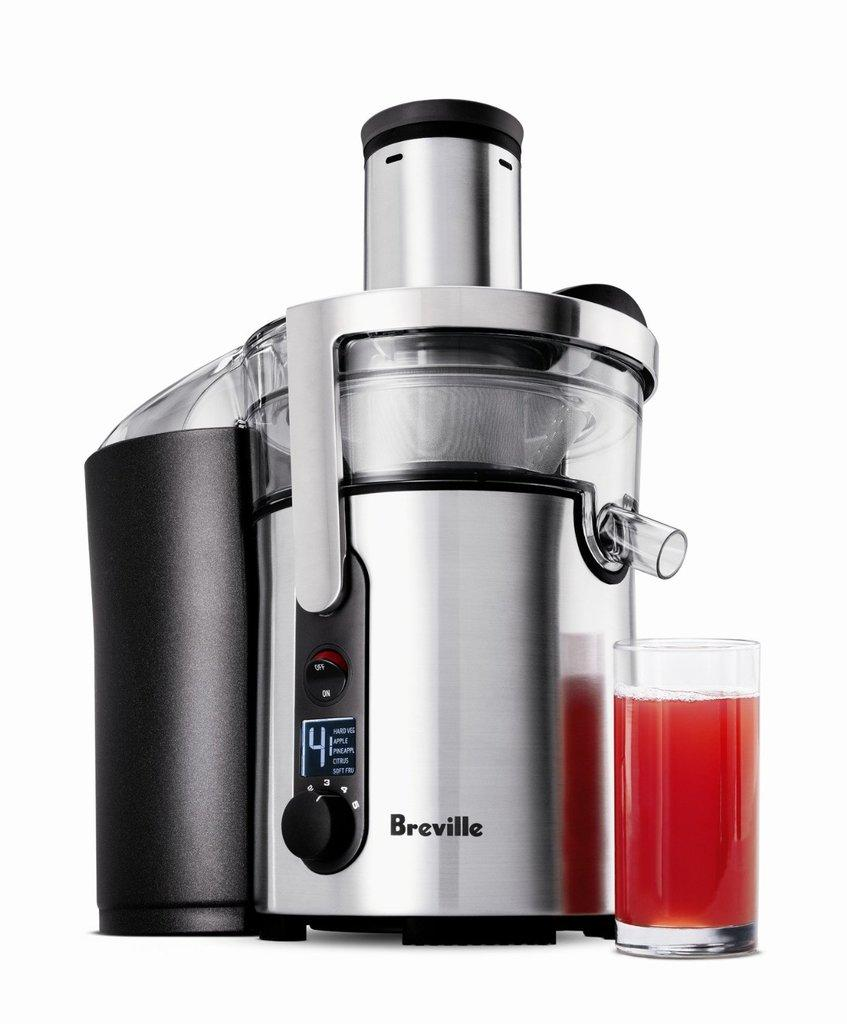Provide a one-sentence caption for the provided image. A silver and black electronic juicer made by Breville. 